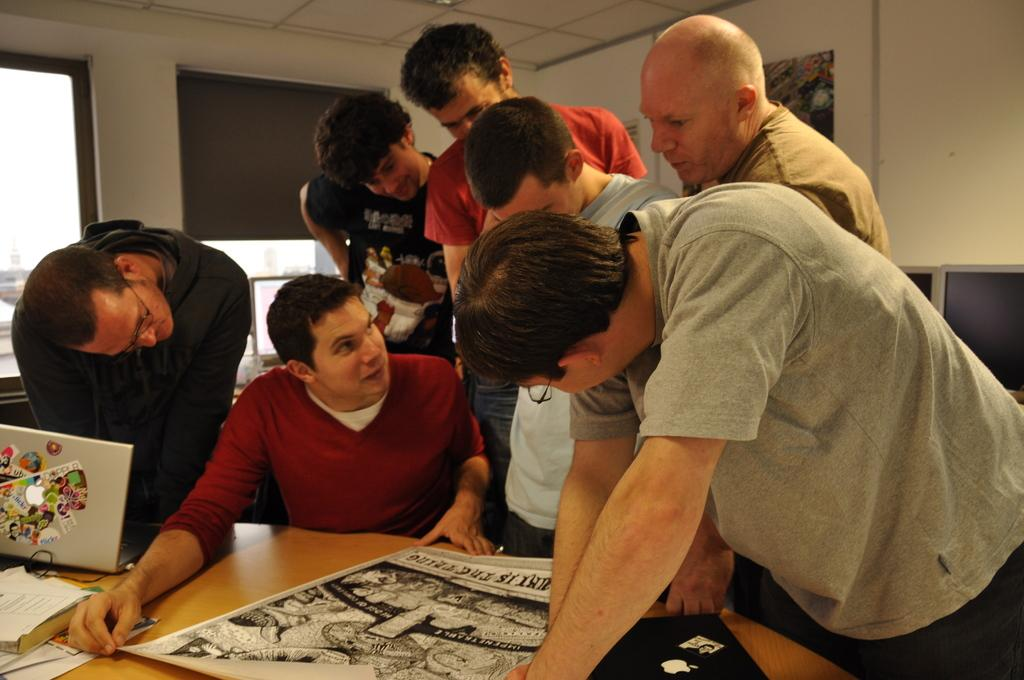How many people are in the image? There are persons in the image, but the exact number cannot be determined from the provided facts. What is on the table in the image? There is a laptop, a book, and papers on the table in the image. What type of electronic devices are present in the image? There are monitors in the image. What can be seen through the windows in the image? The presence of windows in the image suggests that there might be a view or scenery visible, but the specifics cannot be determined from the provided facts. What is visible in the background of the image? There is a wall visible in the background of the image. How many snails are crawling on the laptop in the image? There are no snails present in the image, so it is not possible to determine their number or location. 